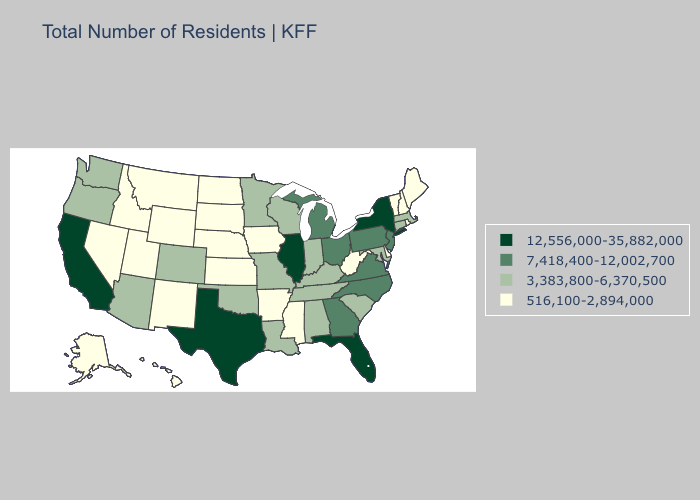Name the states that have a value in the range 7,418,400-12,002,700?
Answer briefly. Georgia, Michigan, New Jersey, North Carolina, Ohio, Pennsylvania, Virginia. Which states have the highest value in the USA?
Concise answer only. California, Florida, Illinois, New York, Texas. Does Ohio have the lowest value in the USA?
Keep it brief. No. What is the highest value in the USA?
Give a very brief answer. 12,556,000-35,882,000. What is the lowest value in the West?
Give a very brief answer. 516,100-2,894,000. What is the lowest value in the MidWest?
Answer briefly. 516,100-2,894,000. What is the value of Delaware?
Write a very short answer. 516,100-2,894,000. What is the highest value in the USA?
Short answer required. 12,556,000-35,882,000. What is the value of Nebraska?
Answer briefly. 516,100-2,894,000. Among the states that border Iowa , does Illinois have the highest value?
Concise answer only. Yes. Does New York have the highest value in the Northeast?
Short answer required. Yes. Does California have a lower value than Missouri?
Concise answer only. No. Name the states that have a value in the range 516,100-2,894,000?
Concise answer only. Alaska, Arkansas, Delaware, Hawaii, Idaho, Iowa, Kansas, Maine, Mississippi, Montana, Nebraska, Nevada, New Hampshire, New Mexico, North Dakota, Rhode Island, South Dakota, Utah, Vermont, West Virginia, Wyoming. Name the states that have a value in the range 516,100-2,894,000?
Short answer required. Alaska, Arkansas, Delaware, Hawaii, Idaho, Iowa, Kansas, Maine, Mississippi, Montana, Nebraska, Nevada, New Hampshire, New Mexico, North Dakota, Rhode Island, South Dakota, Utah, Vermont, West Virginia, Wyoming. Name the states that have a value in the range 7,418,400-12,002,700?
Be succinct. Georgia, Michigan, New Jersey, North Carolina, Ohio, Pennsylvania, Virginia. 